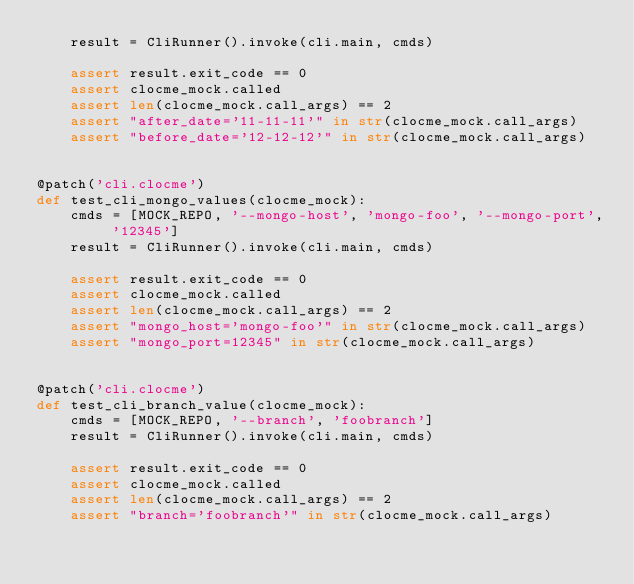<code> <loc_0><loc_0><loc_500><loc_500><_Python_>    result = CliRunner().invoke(cli.main, cmds)

    assert result.exit_code == 0
    assert clocme_mock.called
    assert len(clocme_mock.call_args) == 2
    assert "after_date='11-11-11'" in str(clocme_mock.call_args)
    assert "before_date='12-12-12'" in str(clocme_mock.call_args)


@patch('cli.clocme')
def test_cli_mongo_values(clocme_mock):
    cmds = [MOCK_REPO, '--mongo-host', 'mongo-foo', '--mongo-port', '12345']
    result = CliRunner().invoke(cli.main, cmds)

    assert result.exit_code == 0
    assert clocme_mock.called
    assert len(clocme_mock.call_args) == 2
    assert "mongo_host='mongo-foo'" in str(clocme_mock.call_args)
    assert "mongo_port=12345" in str(clocme_mock.call_args)


@patch('cli.clocme')
def test_cli_branch_value(clocme_mock):
    cmds = [MOCK_REPO, '--branch', 'foobranch']
    result = CliRunner().invoke(cli.main, cmds)

    assert result.exit_code == 0
    assert clocme_mock.called
    assert len(clocme_mock.call_args) == 2
    assert "branch='foobranch'" in str(clocme_mock.call_args)
</code> 